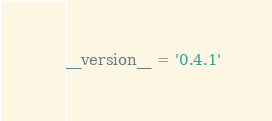Convert code to text. <code><loc_0><loc_0><loc_500><loc_500><_Python_>__version__ = '0.4.1'

</code> 